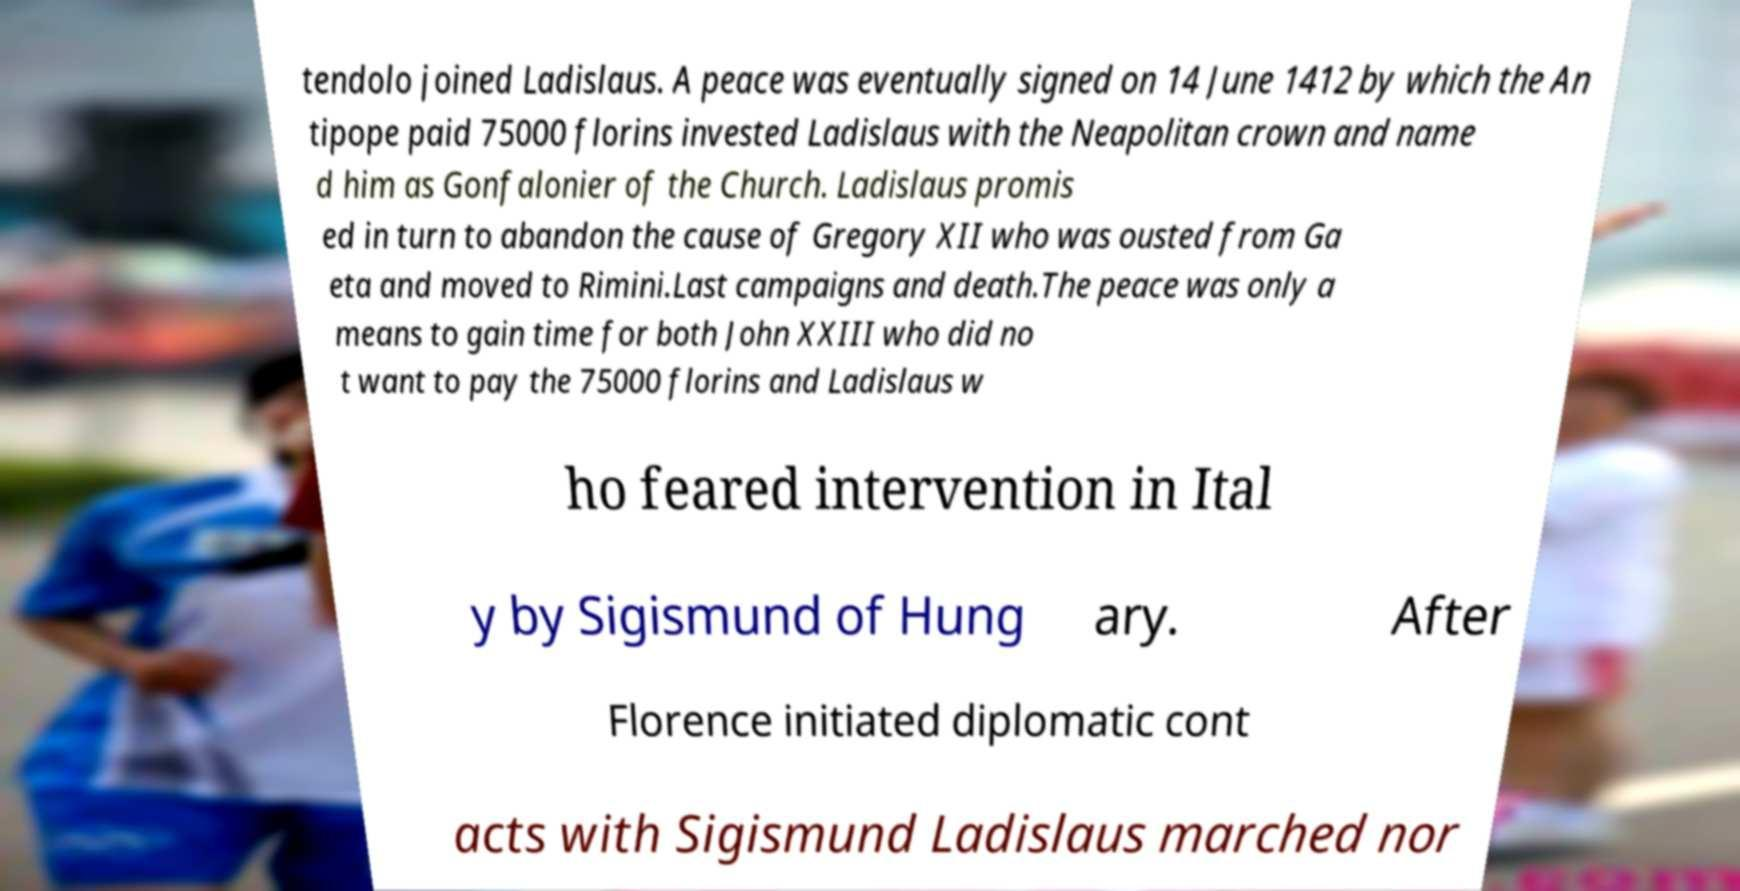Please read and relay the text visible in this image. What does it say? tendolo joined Ladislaus. A peace was eventually signed on 14 June 1412 by which the An tipope paid 75000 florins invested Ladislaus with the Neapolitan crown and name d him as Gonfalonier of the Church. Ladislaus promis ed in turn to abandon the cause of Gregory XII who was ousted from Ga eta and moved to Rimini.Last campaigns and death.The peace was only a means to gain time for both John XXIII who did no t want to pay the 75000 florins and Ladislaus w ho feared intervention in Ital y by Sigismund of Hung ary. After Florence initiated diplomatic cont acts with Sigismund Ladislaus marched nor 